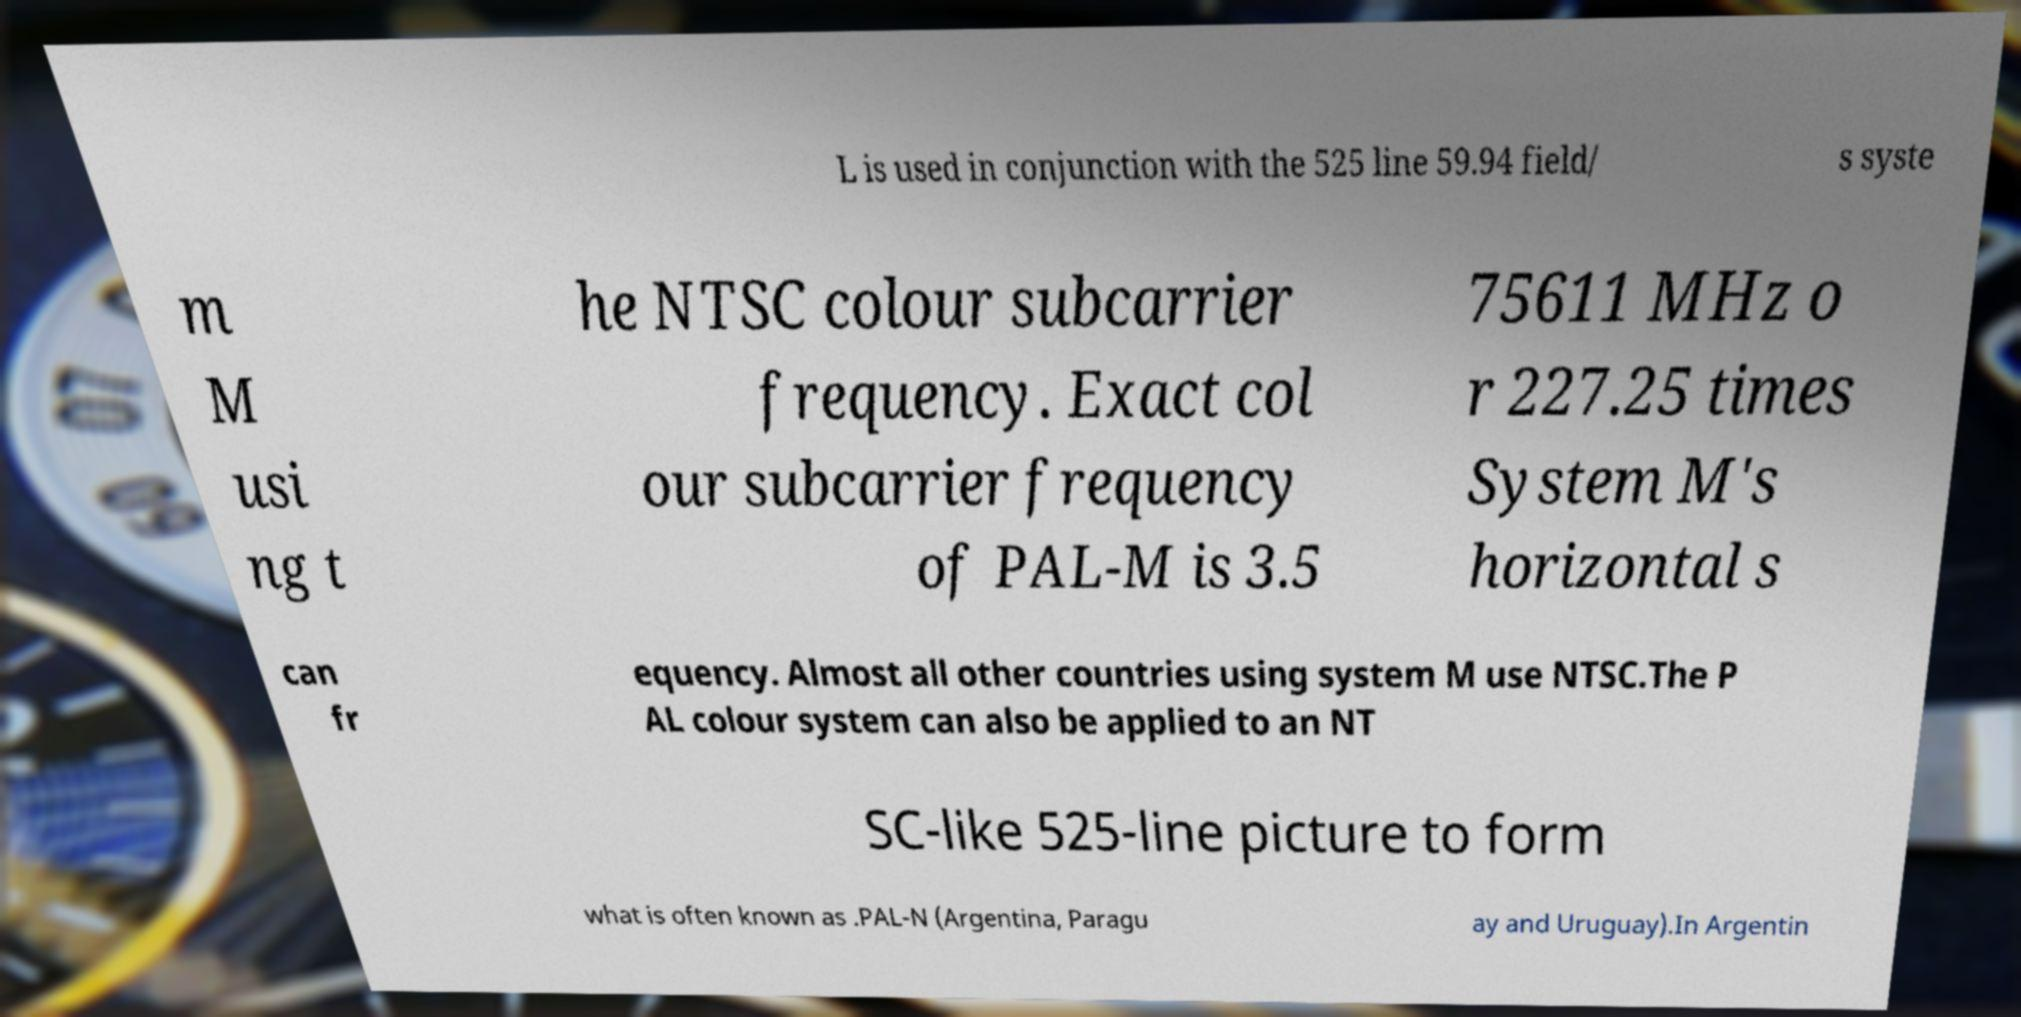What messages or text are displayed in this image? I need them in a readable, typed format. L is used in conjunction with the 525 line 59.94 field/ s syste m M usi ng t he NTSC colour subcarrier frequency. Exact col our subcarrier frequency of PAL-M is 3.5 75611 MHz o r 227.25 times System M's horizontal s can fr equency. Almost all other countries using system M use NTSC.The P AL colour system can also be applied to an NT SC-like 525-line picture to form what is often known as .PAL-N (Argentina, Paragu ay and Uruguay).In Argentin 